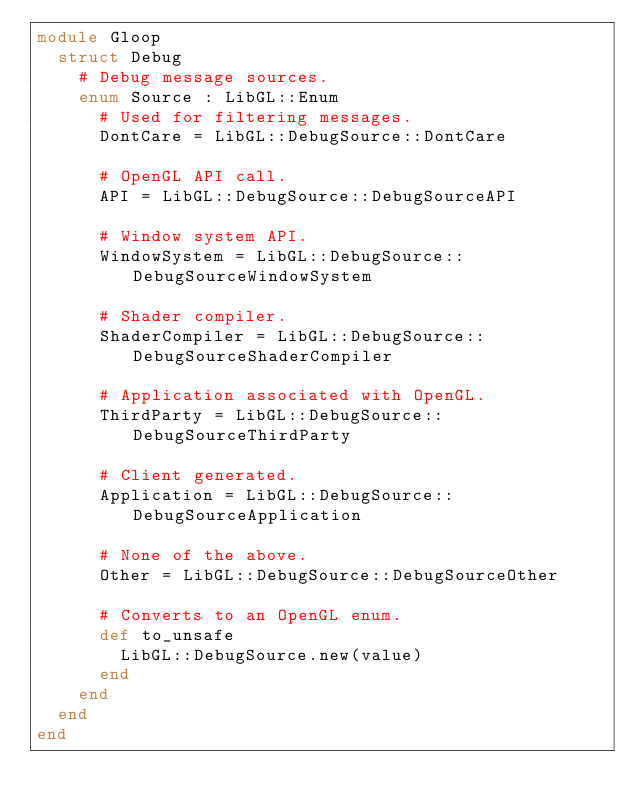<code> <loc_0><loc_0><loc_500><loc_500><_Crystal_>module Gloop
  struct Debug
    # Debug message sources.
    enum Source : LibGL::Enum
      # Used for filtering messages.
      DontCare = LibGL::DebugSource::DontCare

      # OpenGL API call.
      API = LibGL::DebugSource::DebugSourceAPI

      # Window system API.
      WindowSystem = LibGL::DebugSource::DebugSourceWindowSystem

      # Shader compiler.
      ShaderCompiler = LibGL::DebugSource::DebugSourceShaderCompiler

      # Application associated with OpenGL.
      ThirdParty = LibGL::DebugSource::DebugSourceThirdParty

      # Client generated.
      Application = LibGL::DebugSource::DebugSourceApplication

      # None of the above.
      Other = LibGL::DebugSource::DebugSourceOther

      # Converts to an OpenGL enum.
      def to_unsafe
        LibGL::DebugSource.new(value)
      end
    end
  end
end
</code> 